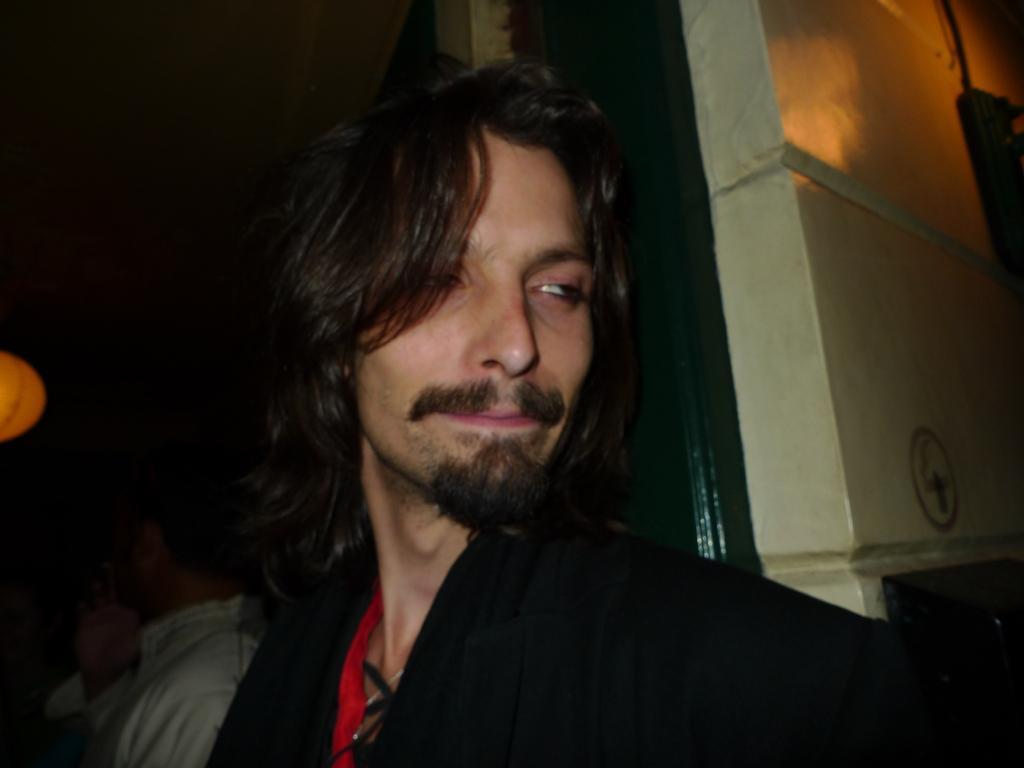Describe this image in one or two sentences. In the foreground of this image, there is a man behind him, there is a wall. In the background, there are people in the dark and the lantern on the left. 